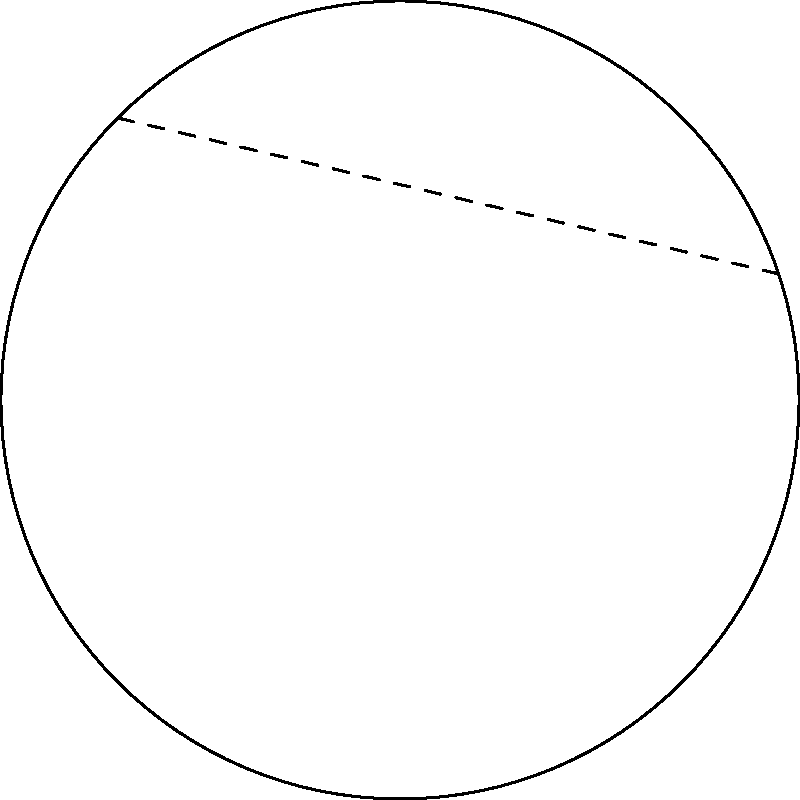On your classic Les Paul guitar, you notice two points on its curved body. If the guitar's surface is considered a non-Euclidean space, what would be the shortest path between these two points? How does this compare to the path you'd take if you were stringing a straight line between them? To understand the shortest path between two points on a non-Euclidean surface like a guitar's curved body, we need to consider the following steps:

1. In Euclidean geometry, the shortest path between two points is always a straight line. However, on a curved surface, this is not the case.

2. The guitar's body can be approximated as a portion of a sphere or a similar curved surface. In non-Euclidean geometry, specifically on a spherical surface, the shortest path between two points is called a geodesic.

3. On a sphere (or a portion of it), the geodesic is represented by a great circle. A great circle is the intersection of a sphere with a plane that passes through the center of the sphere.

4. In our case, the shortest path between the two points on the guitar's body would follow the curvature of the surface, forming an arc of a great circle (if we extend the guitar's surface to a complete sphere).

5. This curved path, although longer in Euclidean space, is actually shorter on the surface of the guitar than a "straight" line would be if you could draw it directly between the points.

6. The straight line between the points (as seen in the dashed line in the diagram) would actually require leaving the surface of the guitar, which is not possible when constrained to move along the surface.

7. The difference between the geodesic (curved red line in the diagram) and the Euclidean straight line (dashed line) illustrates the fundamental difference between Euclidean and non-Euclidean geometry.
Answer: The shortest path is a geodesic curve following the guitar's surface, not a straight line. 